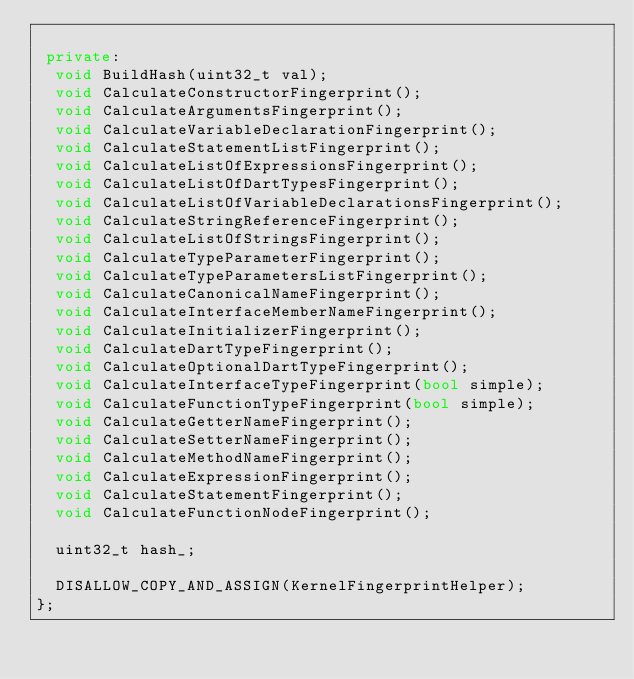<code> <loc_0><loc_0><loc_500><loc_500><_C++_>
 private:
  void BuildHash(uint32_t val);
  void CalculateConstructorFingerprint();
  void CalculateArgumentsFingerprint();
  void CalculateVariableDeclarationFingerprint();
  void CalculateStatementListFingerprint();
  void CalculateListOfExpressionsFingerprint();
  void CalculateListOfDartTypesFingerprint();
  void CalculateListOfVariableDeclarationsFingerprint();
  void CalculateStringReferenceFingerprint();
  void CalculateListOfStringsFingerprint();
  void CalculateTypeParameterFingerprint();
  void CalculateTypeParametersListFingerprint();
  void CalculateCanonicalNameFingerprint();
  void CalculateInterfaceMemberNameFingerprint();
  void CalculateInitializerFingerprint();
  void CalculateDartTypeFingerprint();
  void CalculateOptionalDartTypeFingerprint();
  void CalculateInterfaceTypeFingerprint(bool simple);
  void CalculateFunctionTypeFingerprint(bool simple);
  void CalculateGetterNameFingerprint();
  void CalculateSetterNameFingerprint();
  void CalculateMethodNameFingerprint();
  void CalculateExpressionFingerprint();
  void CalculateStatementFingerprint();
  void CalculateFunctionNodeFingerprint();

  uint32_t hash_;

  DISALLOW_COPY_AND_ASSIGN(KernelFingerprintHelper);
};
</code> 